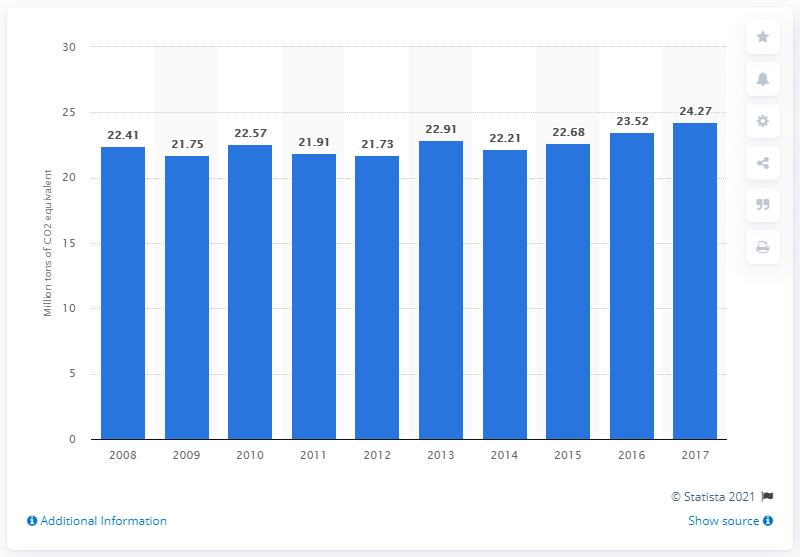Outline some significant characteristics in this image. In 2017, the production of CO2 equivalent from fuel combustion in Austria was 22.21... 